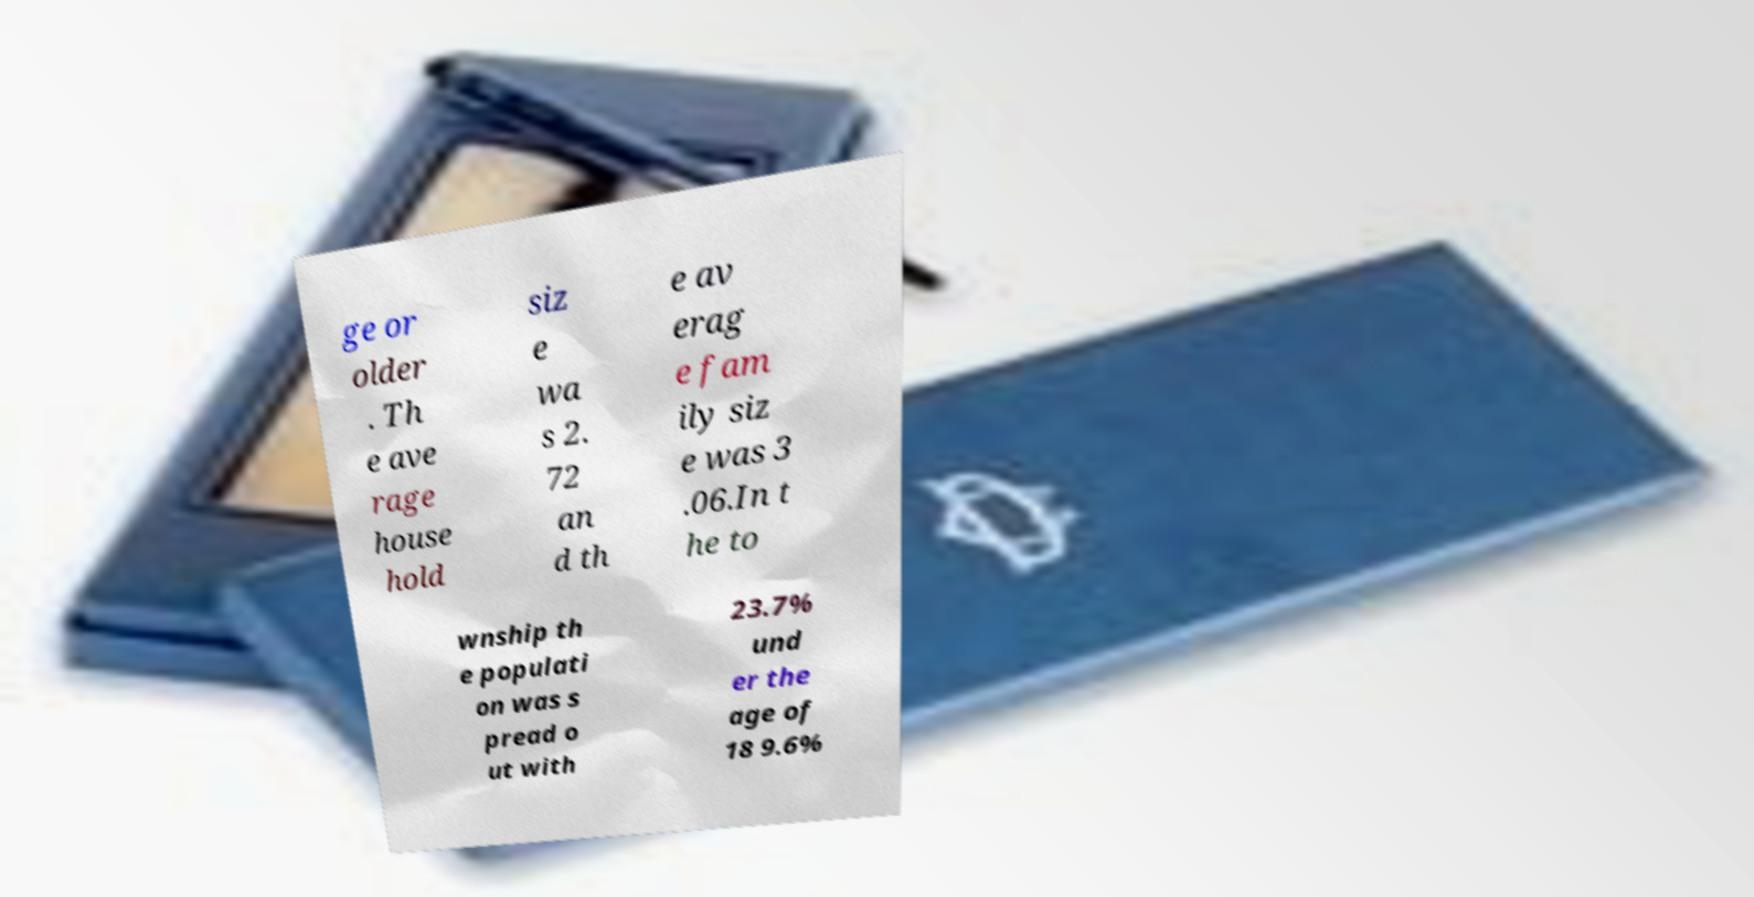I need the written content from this picture converted into text. Can you do that? ge or older . Th e ave rage house hold siz e wa s 2. 72 an d th e av erag e fam ily siz e was 3 .06.In t he to wnship th e populati on was s pread o ut with 23.7% und er the age of 18 9.6% 